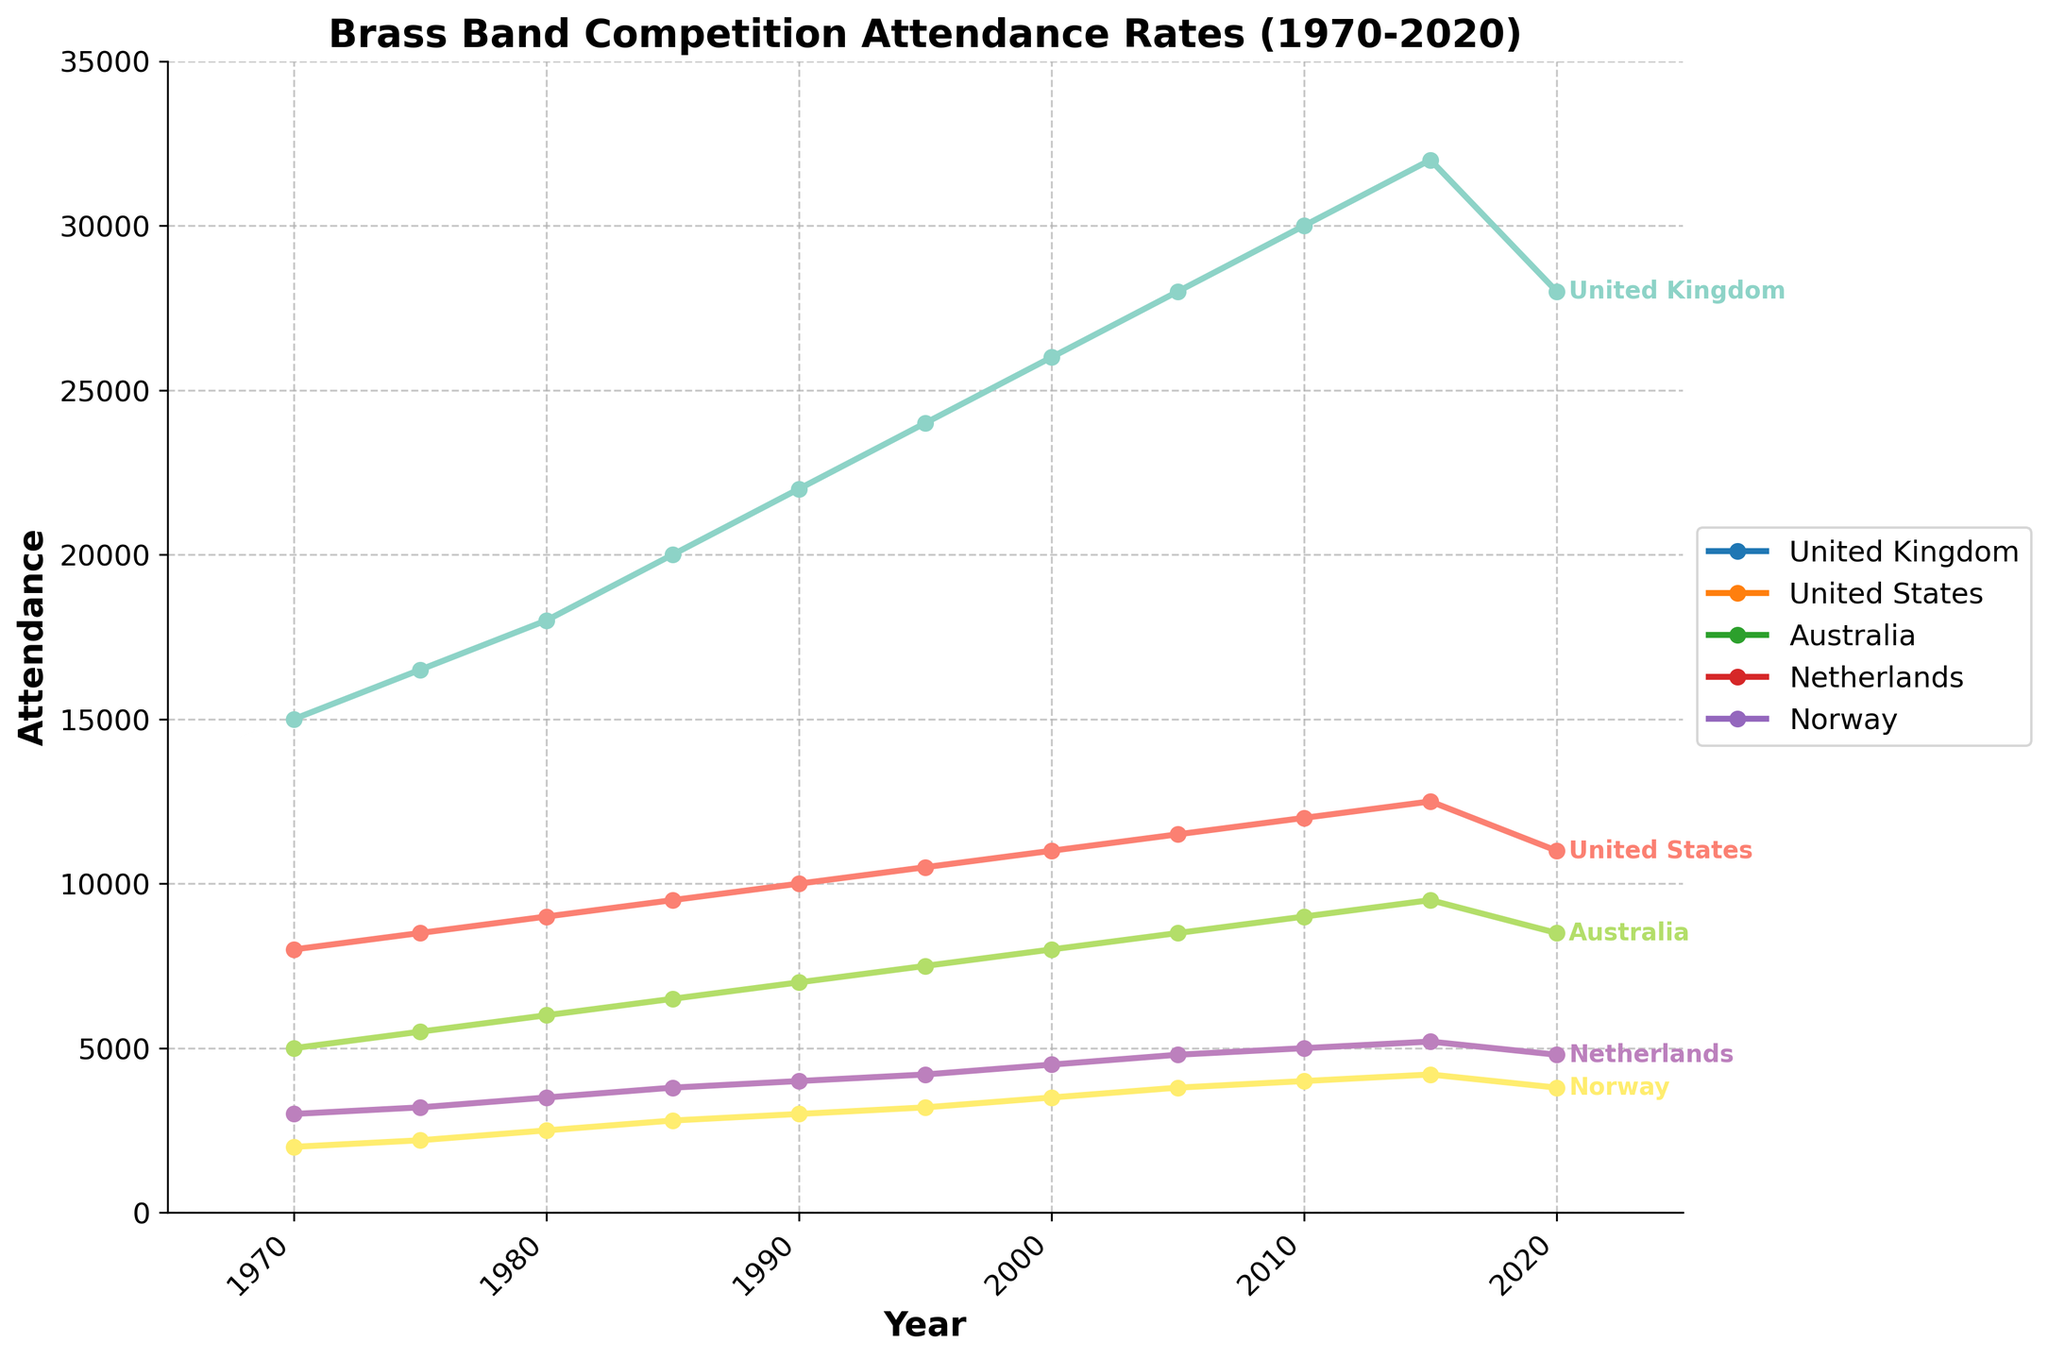Which country had the highest attendance rate in 2020? To determine the country with the highest attendance in 2020, look at the values for each country in the year 2020. The United Kingdom has an attendance rate of 28,000, which is the highest.
Answer: United Kingdom What is the difference in attendance rates between the United Kingdom and Norway in 1995? Find the attendance rates for both the United Kingdom and Norway in 1995, which are 24,000 and 3,200 respectively. Subtract Norway's value from the United Kingdom's value: 24,000 - 3,200 = 20,800.
Answer: 20,800 How did the attendance rate in the United States change from 1970 to 1985? Check the attendance rates in the United States for the years 1970 and 1985. In 1970, it was 8,000; in 1985, it rose to 9,500. Calculate the change: 9,500 - 8,000 = 1,500.
Answer: Increased by 1,500 Which country experienced the smallest increase in attendance rates between 1990 and 2000? Compare the attendance rates in 1990 and 2000 for each country, then calculate the increments. Norway: 3,500 - 3,000 = 500; the Netherlands: 4,500 - 4,000 = 500; Australia: 8,000 - 7,000 = 1,000; United States: 11,000 - 10,000 = 1,000; United Kingdom: 26,000 - 22,000 = 4,000. Both Norway and the Netherlands experienced the smallest increase of 500 attendees.
Answer: Norway and Netherlands What is the average attendance rate in Australia over the 50 years? Add up all the attendance rates in Australia from 1970 to 2020: 5000 + 5500 + 6000 + 6500 + 7000 + 7500 + 8000 + 8500 + 9000 + 9500 + 8500 = 80,000. Divide by the number of years (11): 80,000 / 11 ≈ 7,273.
Answer: 7,273 Compare the trends in attendance rates for the United Kingdom and the Netherlands between 1970 and 2015. Look at the trends over the given years. Both the United Kingdom and the Netherlands show an overall increasing trend from 1970 to 2015. The United Kingdom's attendance grows more rapidly compared to the Netherlands, reaching much higher attendance values. The Netherlands follows a steadier increase.
Answer: Both increased, but UK increased faster In which period did the United Kingdom experience the highest increase in attendance rates? Examine the increments in attendance rates between consecutive years, identifying the largest difference: From 1985 to 1990: (22,000 - 20,000) = 2,000 (this is the highest increase).
Answer: 1985-1990 Based on the visual data, which country's attendance rate had a decline after 2015? Observe the trend lines after 2015. The attendance rates in both the United Kingdom and the United States show a noticeable decline after 2015.
Answer: United Kingdom and United States 